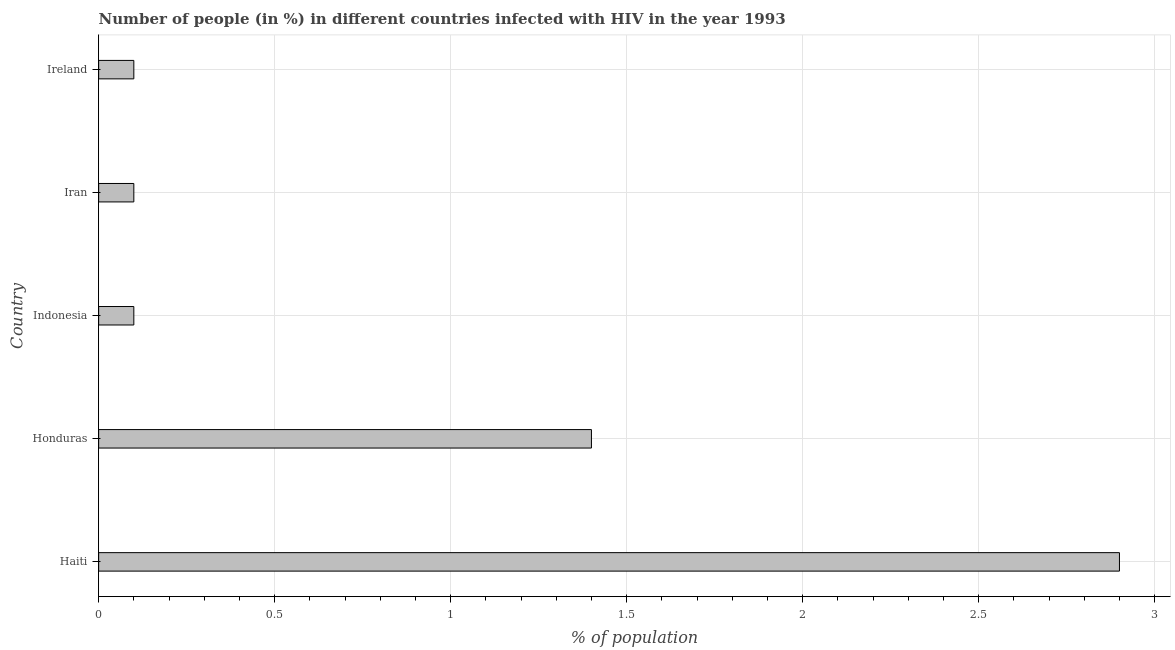Does the graph contain any zero values?
Your answer should be very brief. No. What is the title of the graph?
Offer a terse response. Number of people (in %) in different countries infected with HIV in the year 1993. What is the label or title of the X-axis?
Offer a terse response. % of population. What is the number of people infected with hiv in Iran?
Your answer should be very brief. 0.1. In which country was the number of people infected with hiv maximum?
Give a very brief answer. Haiti. What is the sum of the number of people infected with hiv?
Give a very brief answer. 4.6. What is the difference between the number of people infected with hiv in Honduras and Iran?
Give a very brief answer. 1.3. What is the median number of people infected with hiv?
Offer a terse response. 0.1. In how many countries, is the number of people infected with hiv greater than 1 %?
Offer a terse response. 2. What is the ratio of the number of people infected with hiv in Indonesia to that in Iran?
Provide a succinct answer. 1. In how many countries, is the number of people infected with hiv greater than the average number of people infected with hiv taken over all countries?
Offer a very short reply. 2. Are all the bars in the graph horizontal?
Your response must be concise. Yes. What is the % of population of Indonesia?
Provide a succinct answer. 0.1. What is the difference between the % of population in Haiti and Iran?
Make the answer very short. 2.8. What is the difference between the % of population in Honduras and Indonesia?
Offer a terse response. 1.3. What is the difference between the % of population in Indonesia and Ireland?
Your response must be concise. 0. What is the difference between the % of population in Iran and Ireland?
Provide a short and direct response. 0. What is the ratio of the % of population in Haiti to that in Honduras?
Ensure brevity in your answer.  2.07. What is the ratio of the % of population in Haiti to that in Ireland?
Ensure brevity in your answer.  29. What is the ratio of the % of population in Honduras to that in Ireland?
Your answer should be very brief. 14. 